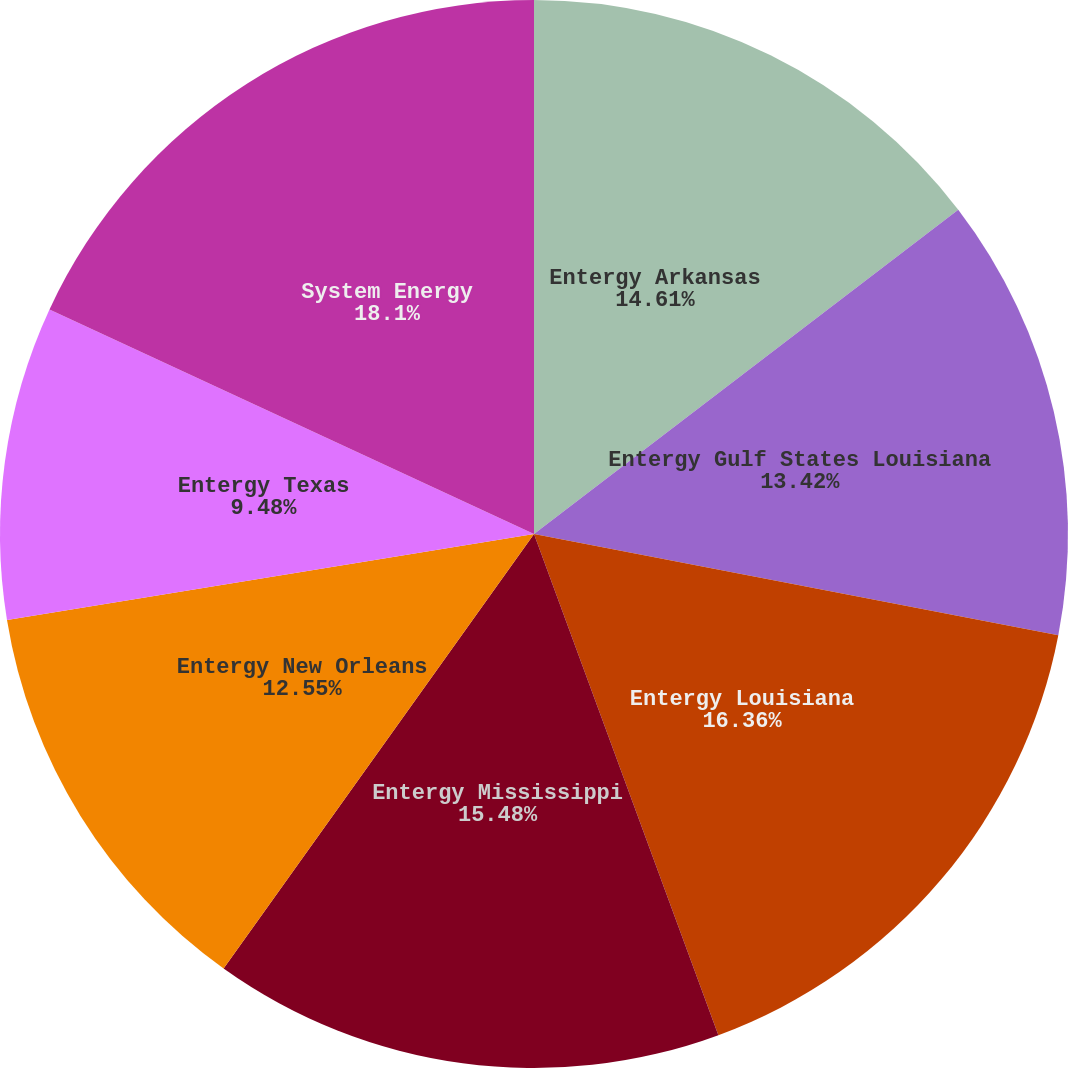Convert chart. <chart><loc_0><loc_0><loc_500><loc_500><pie_chart><fcel>Entergy Arkansas<fcel>Entergy Gulf States Louisiana<fcel>Entergy Louisiana<fcel>Entergy Mississippi<fcel>Entergy New Orleans<fcel>Entergy Texas<fcel>System Energy<nl><fcel>14.61%<fcel>13.42%<fcel>16.35%<fcel>15.48%<fcel>12.55%<fcel>9.48%<fcel>18.09%<nl></chart> 